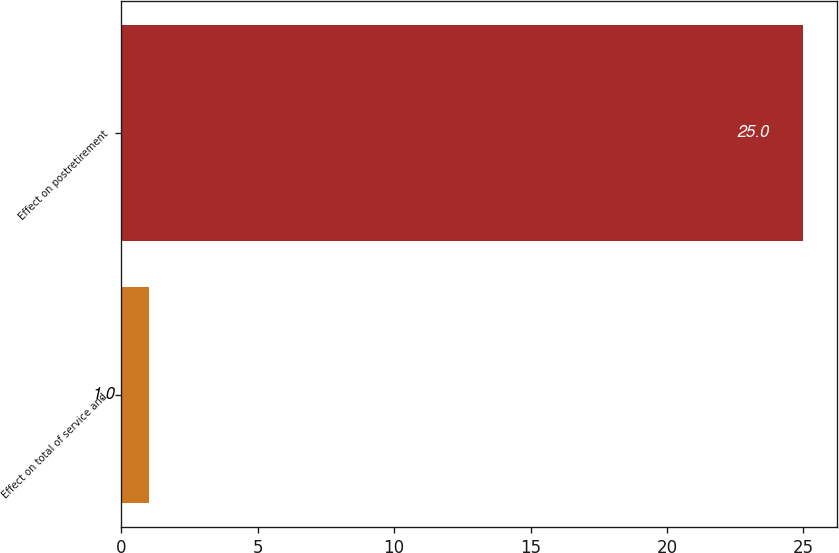<chart> <loc_0><loc_0><loc_500><loc_500><bar_chart><fcel>Effect on total of service and<fcel>Effect on postretirement<nl><fcel>1<fcel>25<nl></chart> 